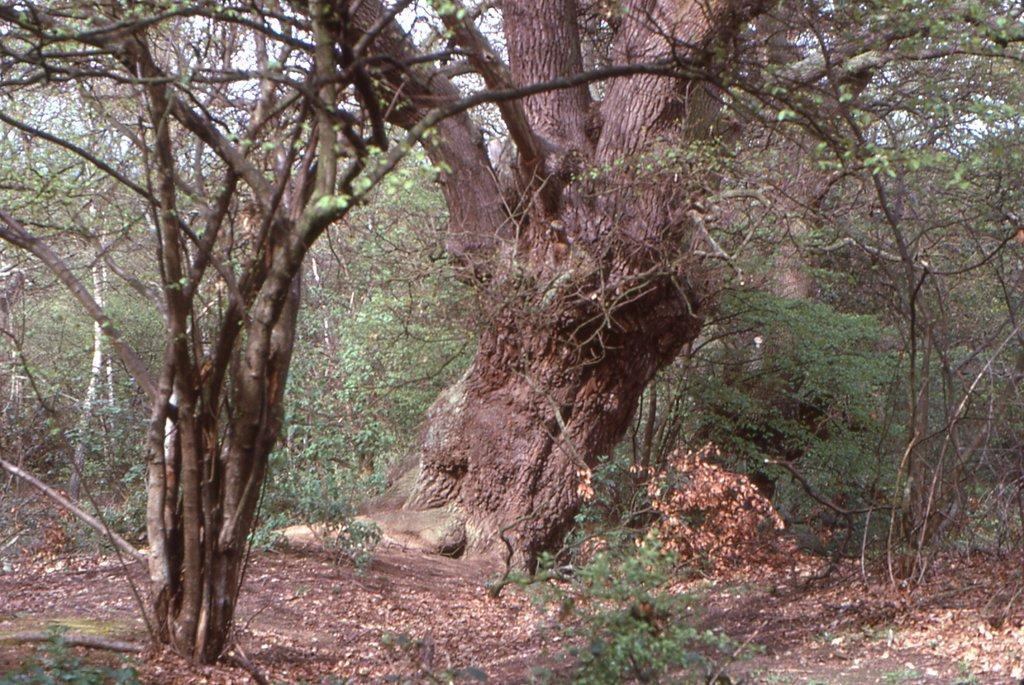What is the main subject in the middle of the image? There is a tree trunk in the middle of the image. What else can be seen around the tree trunk? There are trees surrounding the tree trunk. Can the sky be seen in the image? The sky may be visible behind the trees. How does the tree trunk express its feeling in the image? Trees do not have feelings, so the tree trunk cannot express any feelings in the image. 